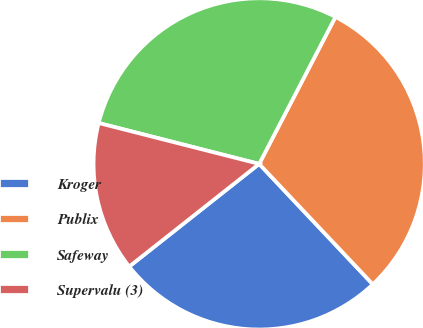<chart> <loc_0><loc_0><loc_500><loc_500><pie_chart><fcel>Kroger<fcel>Publix<fcel>Safeway<fcel>Supervalu (3)<nl><fcel>26.4%<fcel>30.34%<fcel>28.65%<fcel>14.61%<nl></chart> 